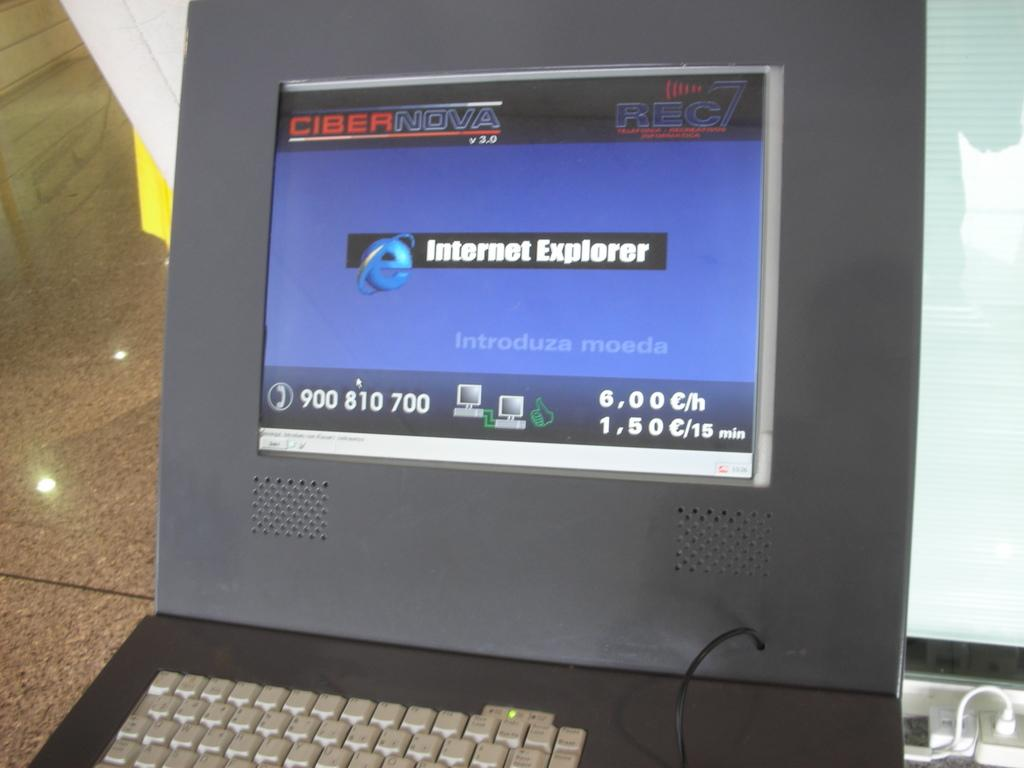Provide a one-sentence caption for the provided image. a screen that is open to a page that says 'internet explorer'. 